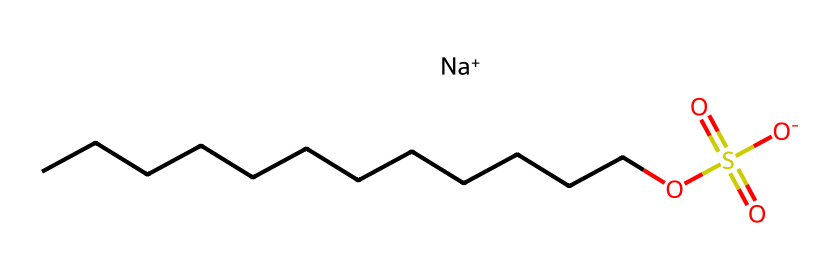What is the total number of carbon atoms in sodium lauryl sulfate? In the provided SMILES representation, the "CCCCCCCCCCCC" part indicates a straight chain of 12 carbon atoms. Therefore, counting those gives us a total of 12 carbon atoms.
Answer: 12 What type of ion is present in this chemical structure? The SMILES shows “[Na+]” indicating the presence of a sodium ion, which carries a positive charge. This reveals that sodium lauryl sulfate contains a metallic cation.
Answer: sodium ion What functional group is represented by "OS(=O)(=O)"? This part of the SMILES corresponds to a sulfonate group, specifically a sulfonic acid derivative. The "S" is sulfur, and its attachment includes double bonds to oxygen, commonly defining the characteristics of a sulfonate.
Answer: sulfonate group How many oxygen atoms are present in the sodium lauryl sulfate structure? From the SMILES, "OS(=O)(=O)[O-]" shows one oxygen attached directly to carbon (the "O" connected to "C") and three associated with the sulfonate group. Therefore, we add them to find a total of four oxygen atoms.
Answer: 4 What is the significance of the long carbon chain in sodium lauryl sulfate? The long carbon chain makes sodium lauryl sulfate a surfactant, which lowers surface tension, enabling the compound to effectively emulsify, cleanse, and create lather in shampoos and other personal care products.
Answer: surfactant What does the presence of the sodium ion indicate about the solubility of sodium lauryl sulfate? The sodium ion contributes to the overall polarity of the molecule due to its charge, which increases the compound's solubility in water, thereby facilitating its role in aqueous formulations such as shampoos.
Answer: increased solubility 